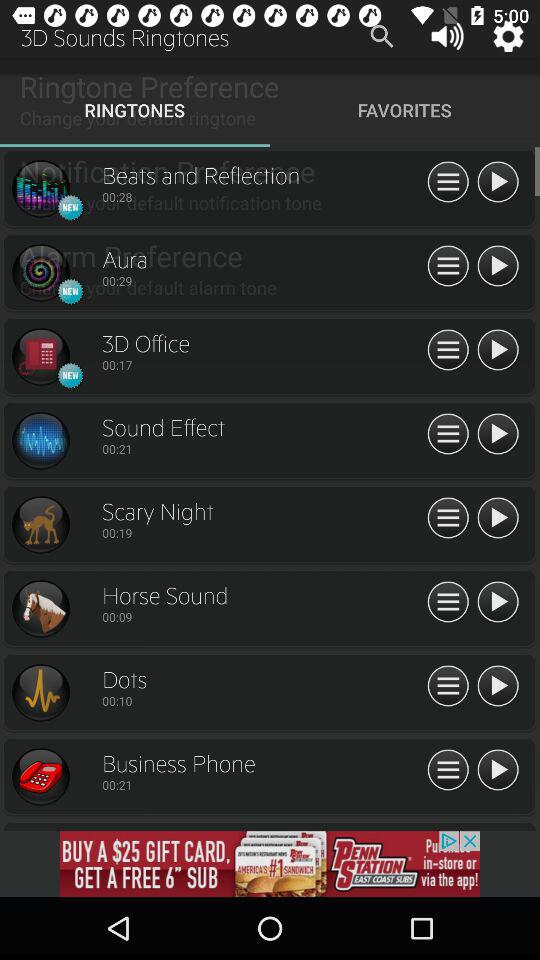What is the duration of the "sound effect" ringtone? The duration is 21 second. 